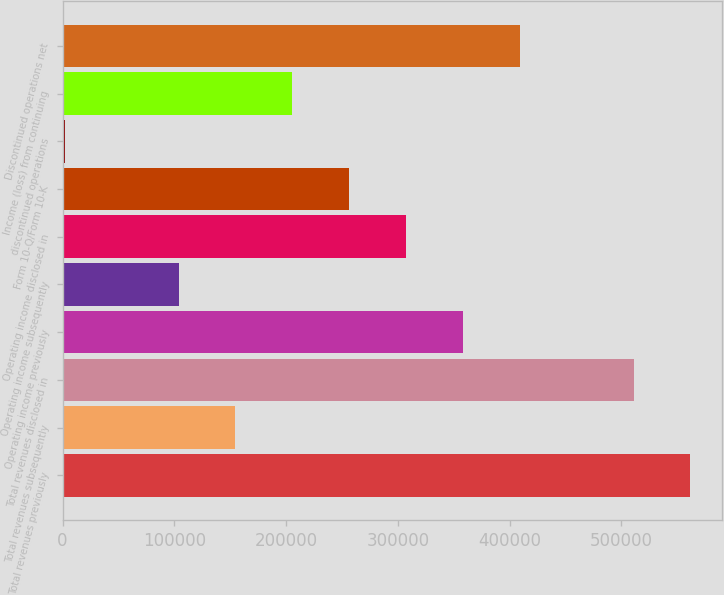Convert chart. <chart><loc_0><loc_0><loc_500><loc_500><bar_chart><fcel>Total revenues previously<fcel>Total revenues subsequently<fcel>Total revenues disclosed in<fcel>Operating income previously<fcel>Operating income subsequently<fcel>Operating income disclosed in<fcel>Form 10-Q/Form 10-K<fcel>discontinued operations<fcel>Income (loss) from continuing<fcel>Discontinued operations net<nl><fcel>561909<fcel>154685<fcel>511006<fcel>358297<fcel>103782<fcel>307394<fcel>256491<fcel>1976<fcel>205588<fcel>409200<nl></chart> 